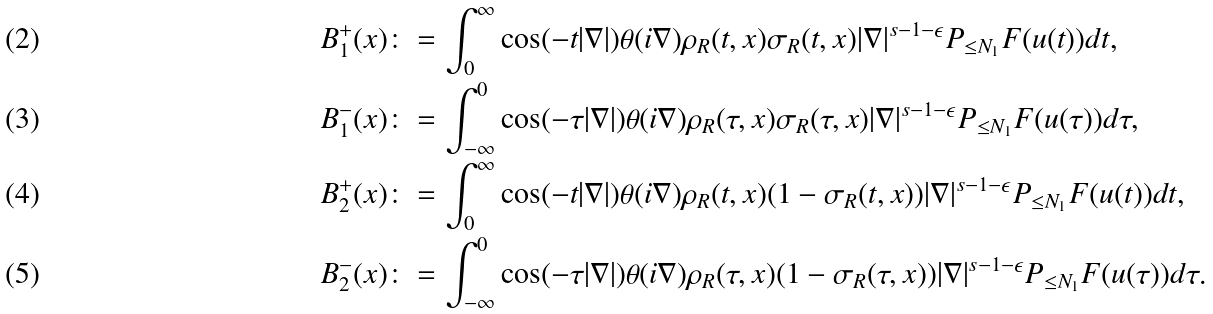Convert formula to latex. <formula><loc_0><loc_0><loc_500><loc_500>B _ { 1 } ^ { + } ( x ) & \colon = \int _ { 0 } ^ { \infty } \cos ( - t | \nabla | ) \theta ( i \nabla ) \rho _ { R } ( t , x ) \sigma _ { R } ( t , x ) | \nabla | ^ { s - 1 - \epsilon } P _ { \leq N _ { 1 } } F ( u ( t ) ) d t , \\ B _ { 1 } ^ { - } ( x ) & \colon = \int _ { - \infty } ^ { 0 } \cos ( - \tau | \nabla | ) \theta ( i \nabla ) \rho _ { R } ( \tau , x ) \sigma _ { R } ( \tau , x ) | \nabla | ^ { s - 1 - \epsilon } P _ { \leq N _ { 1 } } F ( u ( \tau ) ) d \tau , \\ B _ { 2 } ^ { + } ( x ) & \colon = \int _ { 0 } ^ { \infty } \cos ( - t | \nabla | ) \theta ( i \nabla ) \rho _ { R } ( t , x ) ( 1 - \sigma _ { R } ( t , x ) ) | \nabla | ^ { s - 1 - \epsilon } P _ { \leq N _ { 1 } } F ( u ( t ) ) d t , \\ B _ { 2 } ^ { - } ( x ) & \colon = \int _ { - \infty } ^ { 0 } \cos ( - \tau | \nabla | ) \theta ( i \nabla ) \rho _ { R } ( \tau , x ) ( 1 - \sigma _ { R } ( \tau , x ) ) | \nabla | ^ { s - 1 - \epsilon } P _ { \leq N _ { 1 } } F ( u ( \tau ) ) d \tau .</formula> 